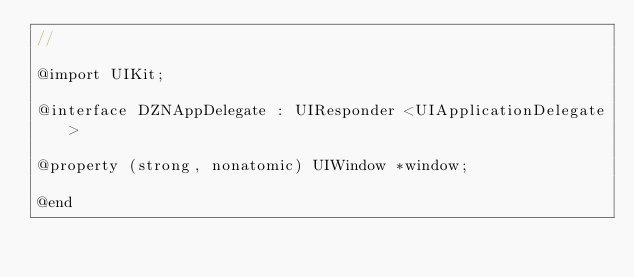Convert code to text. <code><loc_0><loc_0><loc_500><loc_500><_C_>//

@import UIKit;

@interface DZNAppDelegate : UIResponder <UIApplicationDelegate>

@property (strong, nonatomic) UIWindow *window;

@end
</code> 